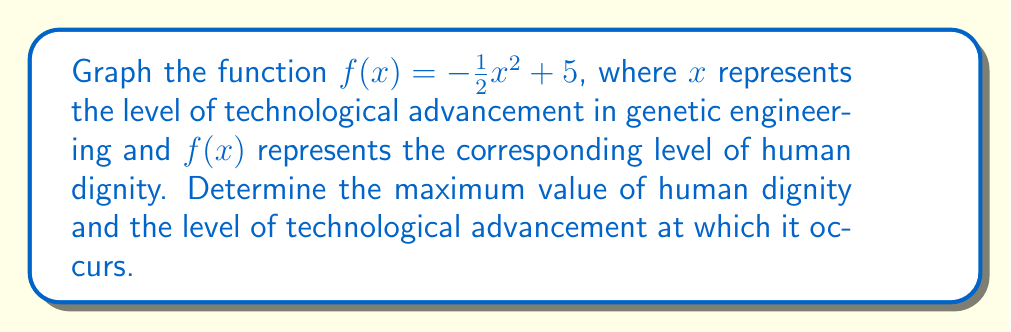Show me your answer to this math problem. 1) The function $f(x) = -\frac{1}{2}x^2 + 5$ is a quadratic function with a negative leading coefficient, forming a parabola that opens downward.

2) To graph this function:
   - The y-intercept is at (0, 5)
   - The axis of symmetry is at $x = 0$ (since $a = -\frac{1}{2}$ and $b = 0$ in the general form $ax^2 + bx + c$)
   - The vertex is at (0, 5), which is the highest point of the parabola

3) To find the maximum value of human dignity:
   - The vertex represents the maximum point of the parabola
   - The y-coordinate of the vertex is 5
   - Therefore, the maximum value of human dignity is 5

4) The level of technological advancement at which this maximum occurs:
   - The x-coordinate of the vertex is 0
   - This indicates that human dignity is at its maximum when there is no advancement in genetic engineering technology

5) As x (technological advancement) increases or decreases from 0, y (human dignity) decreases, forming the downward-opening parabola.

[asy]
import graph;
size(200,200);
real f(real x) {return -0.5*x^2 + 5;}
xaxis("x",arrow=Arrow);
yaxis("y",arrow=Arrow);
draw(graph(f,-4,4));
label("f(x) = -1/2x^2 + 5", (2,4), E);
dot((0,5));
label("(0,5)", (0,5), NE);
[/asy]

This graph illustrates the philosophical argument that any deviation from the natural state (x = 0) in terms of genetic engineering results in a decrease in human dignity.
Answer: Maximum human dignity: 5; occurs at technological advancement level: 0 